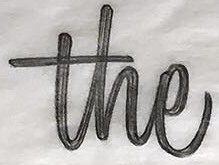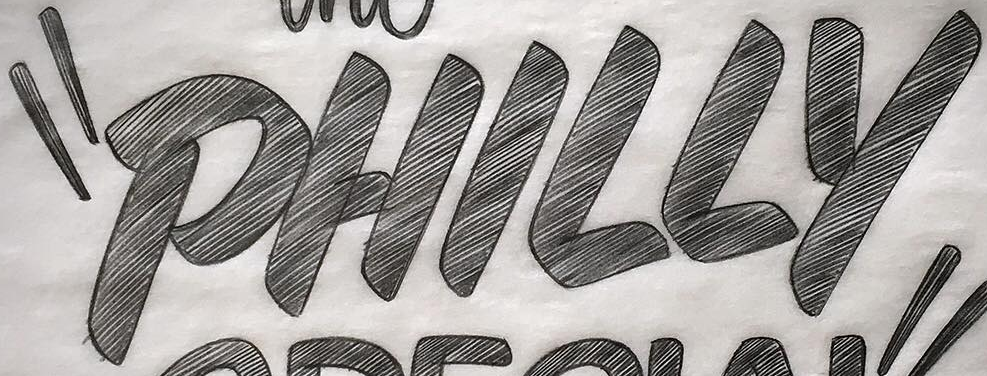Identify the words shown in these images in order, separated by a semicolon. the; "PHILLY 